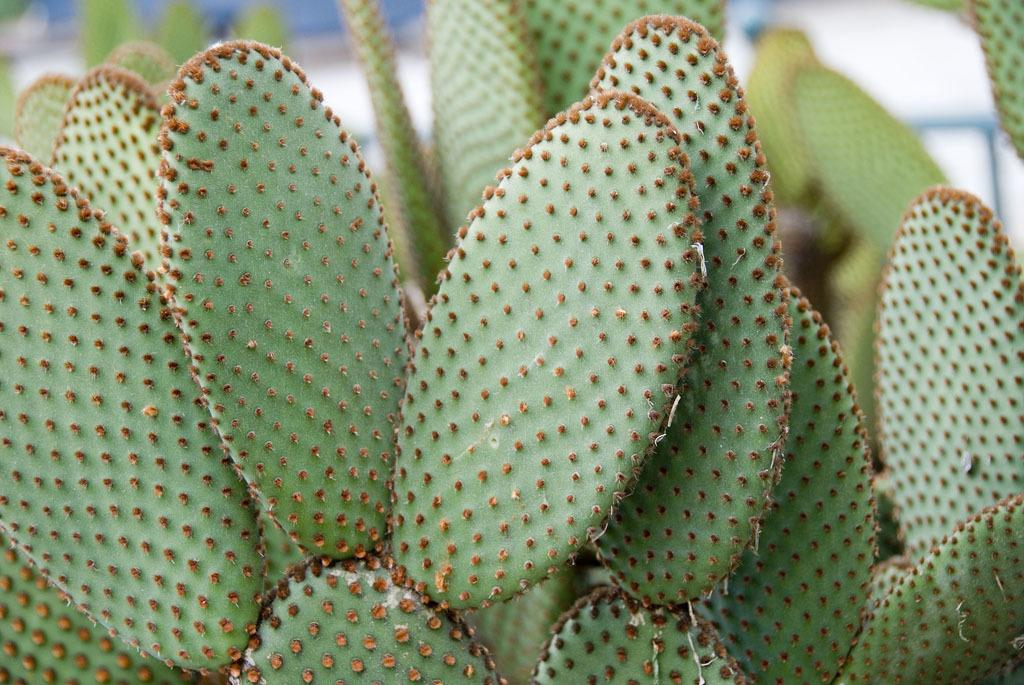What is the primary subject of the image? The primary subject of the image is many plants. Can you describe the background of the image? The background at the top of the image is blurred. What type of thread is being used to hold the watch in the image? There is no watch or thread present in the image; it features many plants and a blurred background. 